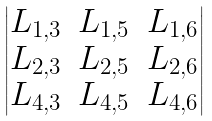Convert formula to latex. <formula><loc_0><loc_0><loc_500><loc_500>\begin{vmatrix} L _ { 1 , 3 } & L _ { 1 , 5 } & L _ { 1 , 6 } \\ L _ { 2 , 3 } & L _ { 2 , 5 } & L _ { 2 , 6 } \\ L _ { 4 , 3 } & L _ { 4 , 5 } & L _ { 4 , 6 } \end{vmatrix}</formula> 